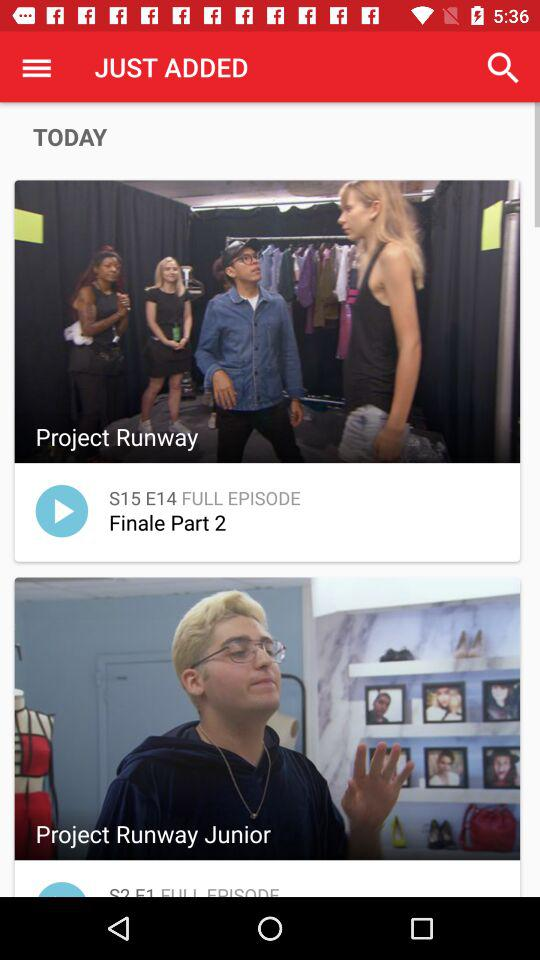How many episodes have been added since yesterday?
Answer the question using a single word or phrase. 2 